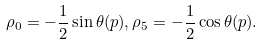Convert formula to latex. <formula><loc_0><loc_0><loc_500><loc_500>\rho _ { 0 } = - \frac { 1 } { 2 } \sin \theta ( p ) , \rho _ { 5 } = - \frac { 1 } { 2 } \cos \theta ( p ) .</formula> 